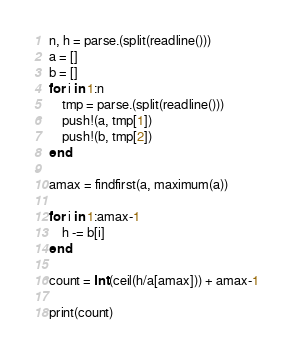Convert code to text. <code><loc_0><loc_0><loc_500><loc_500><_Julia_>n, h = parse.(split(readline()))
a = []
b = []
for i in 1:n
	tmp = parse.(split(readline()))
	push!(a, tmp[1])
	push!(b, tmp[2])
end

amax = findfirst(a, maximum(a))

for i in 1:amax-1
	h -= b[i]
end

count = Int(ceil(h/a[amax])) + amax-1

print(count)</code> 